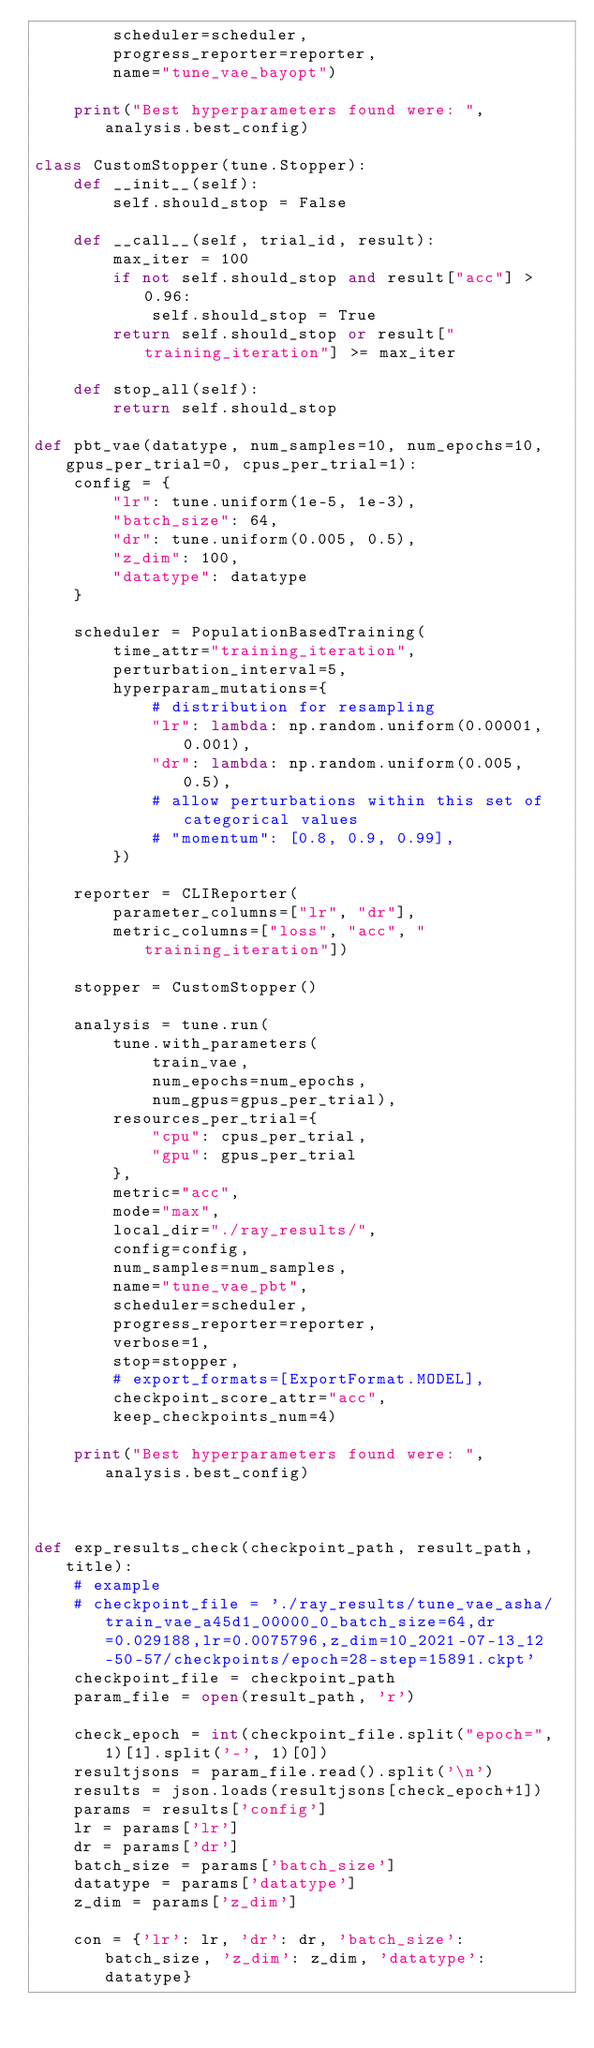Convert code to text. <code><loc_0><loc_0><loc_500><loc_500><_Python_>        scheduler=scheduler,
        progress_reporter=reporter,
        name="tune_vae_bayopt")

    print("Best hyperparameters found were: ", analysis.best_config)

class CustomStopper(tune.Stopper):
    def __init__(self):
        self.should_stop = False

    def __call__(self, trial_id, result):
        max_iter = 100
        if not self.should_stop and result["acc"] > 0.96:
            self.should_stop = True
        return self.should_stop or result["training_iteration"] >= max_iter

    def stop_all(self):
        return self.should_stop

def pbt_vae(datatype, num_samples=10, num_epochs=10, gpus_per_trial=0, cpus_per_trial=1):
    config = {
        "lr": tune.uniform(1e-5, 1e-3),
        "batch_size": 64,
        "dr": tune.uniform(0.005, 0.5),
        "z_dim": 100,
        "datatype": datatype
    }

    scheduler = PopulationBasedTraining(
        time_attr="training_iteration",
        perturbation_interval=5,
        hyperparam_mutations={
            # distribution for resampling
            "lr": lambda: np.random.uniform(0.00001, 0.001),
            "dr": lambda: np.random.uniform(0.005, 0.5),
            # allow perturbations within this set of categorical values
            # "momentum": [0.8, 0.9, 0.99],
        })

    reporter = CLIReporter(
        parameter_columns=["lr", "dr"],
        metric_columns=["loss", "acc", "training_iteration"])

    stopper = CustomStopper()

    analysis = tune.run(
        tune.with_parameters(
            train_vae,
            num_epochs=num_epochs,
            num_gpus=gpus_per_trial),
        resources_per_trial={
            "cpu": cpus_per_trial,
            "gpu": gpus_per_trial
        },
        metric="acc",
        mode="max",
        local_dir="./ray_results/",
        config=config,
        num_samples=num_samples,
        name="tune_vae_pbt",
        scheduler=scheduler,
        progress_reporter=reporter,
        verbose=1,
        stop=stopper,
        # export_formats=[ExportFormat.MODEL],
        checkpoint_score_attr="acc",
        keep_checkpoints_num=4)

    print("Best hyperparameters found were: ", analysis.best_config)



def exp_results_check(checkpoint_path, result_path, title):
    # example
    # checkpoint_file = './ray_results/tune_vae_asha/train_vae_a45d1_00000_0_batch_size=64,dr=0.029188,lr=0.0075796,z_dim=10_2021-07-13_12-50-57/checkpoints/epoch=28-step=15891.ckpt'
    checkpoint_file = checkpoint_path
    param_file = open(result_path, 'r')

    check_epoch = int(checkpoint_file.split("epoch=", 1)[1].split('-', 1)[0])
    resultjsons = param_file.read().split('\n')
    results = json.loads(resultjsons[check_epoch+1])
    params = results['config']
    lr = params['lr']
    dr = params['dr']
    batch_size = params['batch_size']
    datatype = params['datatype']
    z_dim = params['z_dim']

    con = {'lr': lr, 'dr': dr, 'batch_size': batch_size, 'z_dim': z_dim, 'datatype': datatype}</code> 